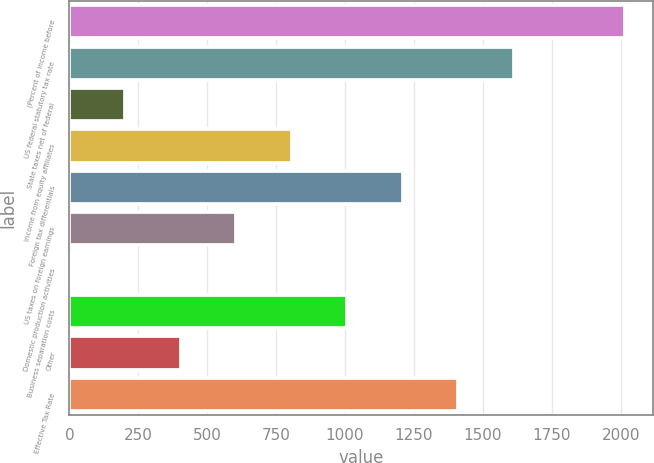Convert chart. <chart><loc_0><loc_0><loc_500><loc_500><bar_chart><fcel>(Percent of income before<fcel>US federal statutory tax rate<fcel>State taxes net of federal<fcel>Income from equity affiliates<fcel>Foreign tax differentials<fcel>US taxes on foreign earnings<fcel>Domestic production activities<fcel>Business separation costs<fcel>Other<fcel>Effective Tax Rate<nl><fcel>2016<fcel>1612.96<fcel>202.32<fcel>806.88<fcel>1209.92<fcel>605.36<fcel>0.8<fcel>1008.4<fcel>403.84<fcel>1411.44<nl></chart> 